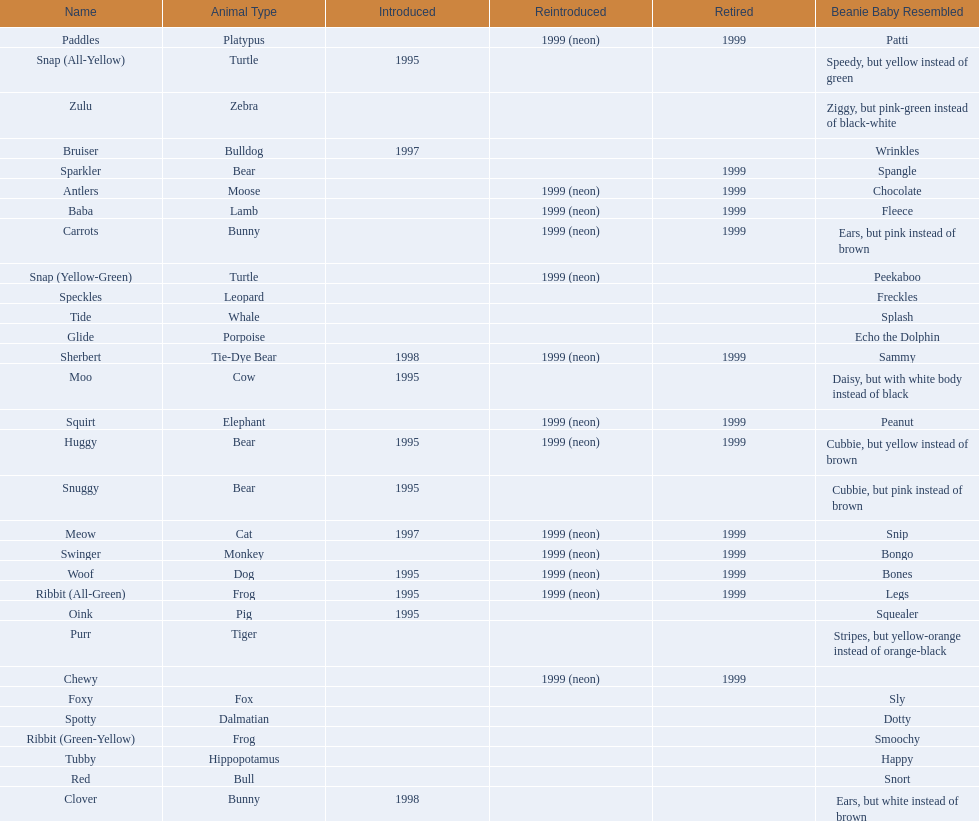What animals are pillow pals? Moose, Lamb, Bulldog, Bunny, Bunny, Fox, Porpoise, Bear, Cat, Cow, Pig, Platypus, Tiger, Bull, Frog, Frog, Tie-Dye Bear, Turtle, Turtle, Bear, Bear, Leopard, Dalmatian, Elephant, Monkey, Whale, Hippopotamus, Dog, Zebra. What is the name of the dalmatian? Spotty. 